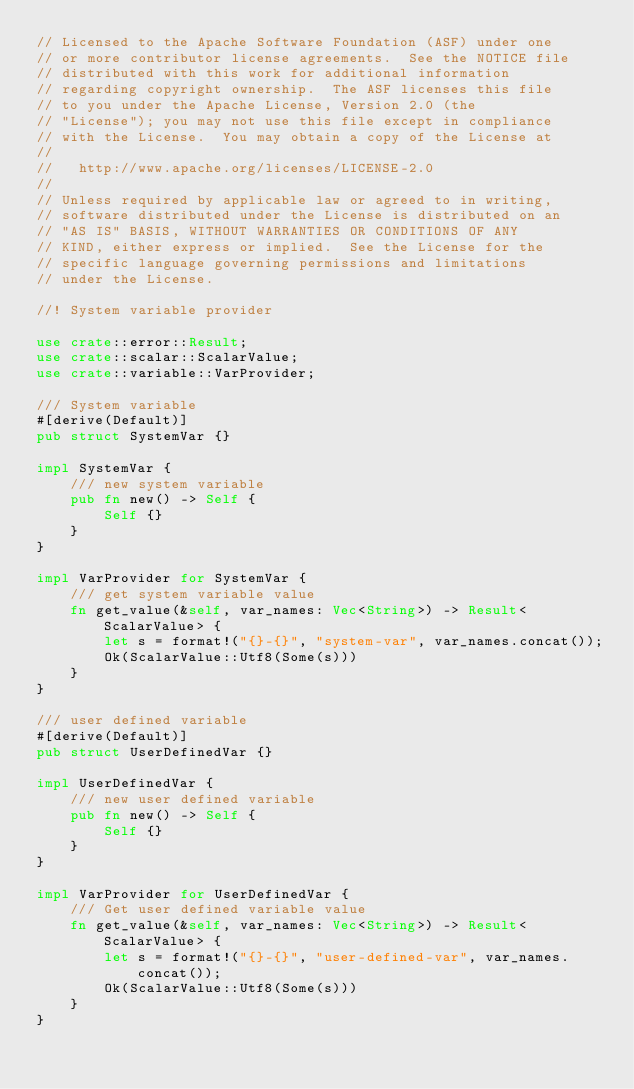<code> <loc_0><loc_0><loc_500><loc_500><_Rust_>// Licensed to the Apache Software Foundation (ASF) under one
// or more contributor license agreements.  See the NOTICE file
// distributed with this work for additional information
// regarding copyright ownership.  The ASF licenses this file
// to you under the Apache License, Version 2.0 (the
// "License"); you may not use this file except in compliance
// with the License.  You may obtain a copy of the License at
//
//   http://www.apache.org/licenses/LICENSE-2.0
//
// Unless required by applicable law or agreed to in writing,
// software distributed under the License is distributed on an
// "AS IS" BASIS, WITHOUT WARRANTIES OR CONDITIONS OF ANY
// KIND, either express or implied.  See the License for the
// specific language governing permissions and limitations
// under the License.

//! System variable provider

use crate::error::Result;
use crate::scalar::ScalarValue;
use crate::variable::VarProvider;

/// System variable
#[derive(Default)]
pub struct SystemVar {}

impl SystemVar {
    /// new system variable
    pub fn new() -> Self {
        Self {}
    }
}

impl VarProvider for SystemVar {
    /// get system variable value
    fn get_value(&self, var_names: Vec<String>) -> Result<ScalarValue> {
        let s = format!("{}-{}", "system-var", var_names.concat());
        Ok(ScalarValue::Utf8(Some(s)))
    }
}

/// user defined variable
#[derive(Default)]
pub struct UserDefinedVar {}

impl UserDefinedVar {
    /// new user defined variable
    pub fn new() -> Self {
        Self {}
    }
}

impl VarProvider for UserDefinedVar {
    /// Get user defined variable value
    fn get_value(&self, var_names: Vec<String>) -> Result<ScalarValue> {
        let s = format!("{}-{}", "user-defined-var", var_names.concat());
        Ok(ScalarValue::Utf8(Some(s)))
    }
}
</code> 